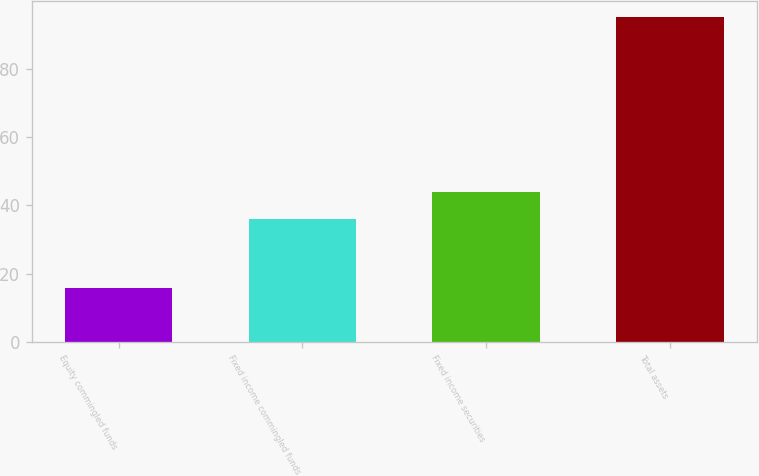Convert chart. <chart><loc_0><loc_0><loc_500><loc_500><bar_chart><fcel>Equity commingled funds<fcel>Fixed income commingled funds<fcel>Fixed income securities<fcel>Total assets<nl><fcel>15.8<fcel>35.9<fcel>43.84<fcel>95.2<nl></chart> 